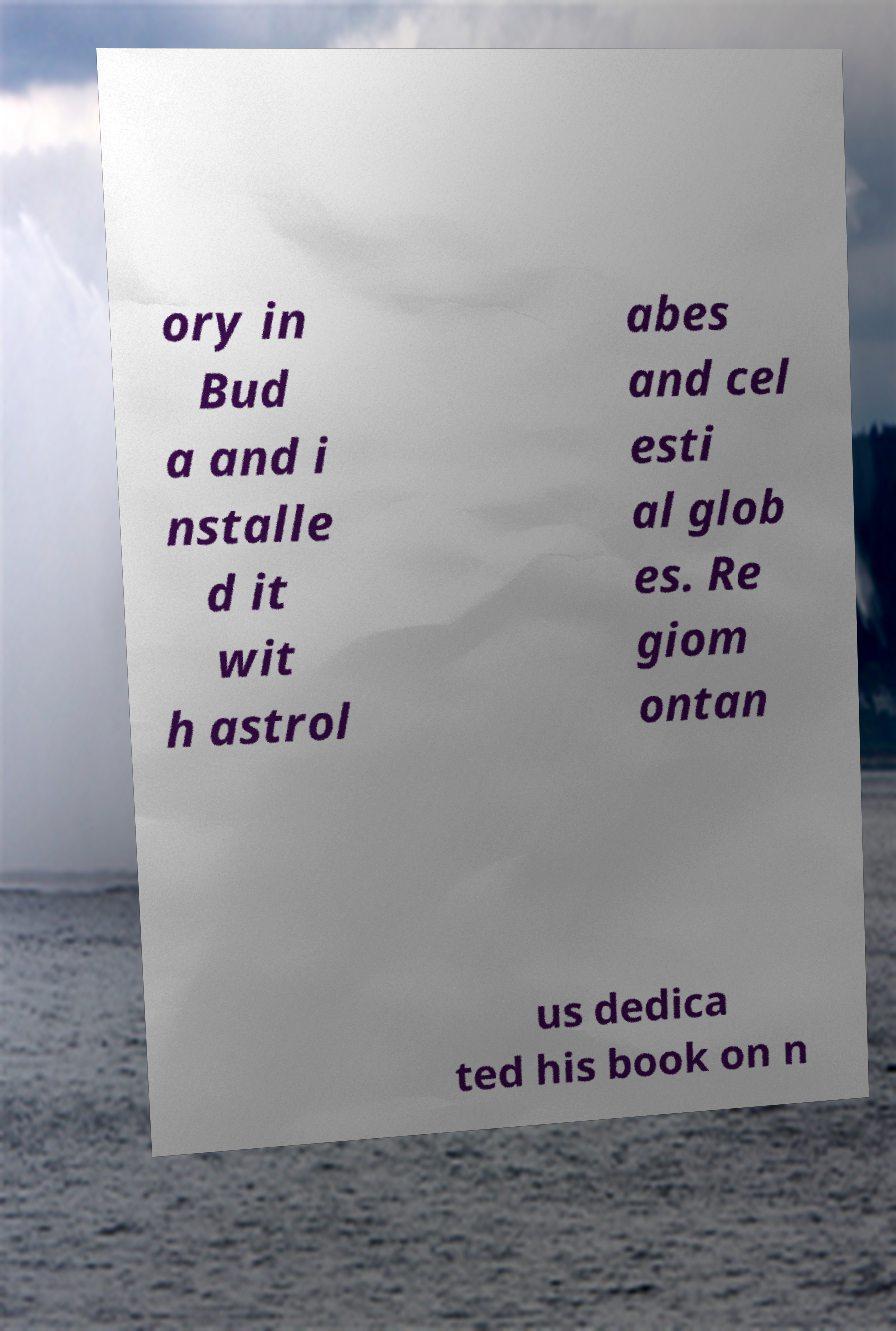For documentation purposes, I need the text within this image transcribed. Could you provide that? ory in Bud a and i nstalle d it wit h astrol abes and cel esti al glob es. Re giom ontan us dedica ted his book on n 